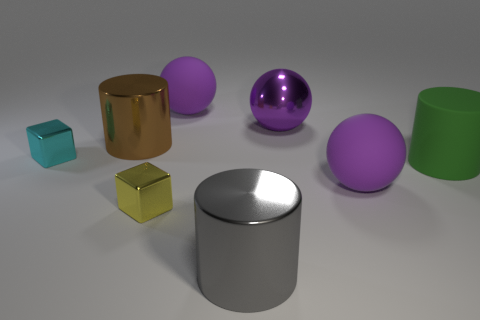There is another small block that is made of the same material as the tiny cyan block; what color is it?
Provide a succinct answer. Yellow. There is a yellow block; is it the same size as the purple thing in front of the large purple metallic thing?
Your answer should be very brief. No. The large gray metallic thing is what shape?
Your answer should be very brief. Cylinder. What number of tiny objects are the same color as the large matte cylinder?
Your response must be concise. 0. The other object that is the same shape as the yellow object is what color?
Provide a succinct answer. Cyan. What number of cyan metal things are behind the big cylinder that is behind the tiny cyan metal block?
Your answer should be compact. 0. What number of cubes are purple rubber objects or yellow metal objects?
Provide a short and direct response. 1. Are any green things visible?
Provide a short and direct response. Yes. The other thing that is the same shape as the tiny cyan thing is what size?
Your answer should be compact. Small. There is a matte object in front of the large cylinder right of the gray thing; what is its shape?
Make the answer very short. Sphere. 